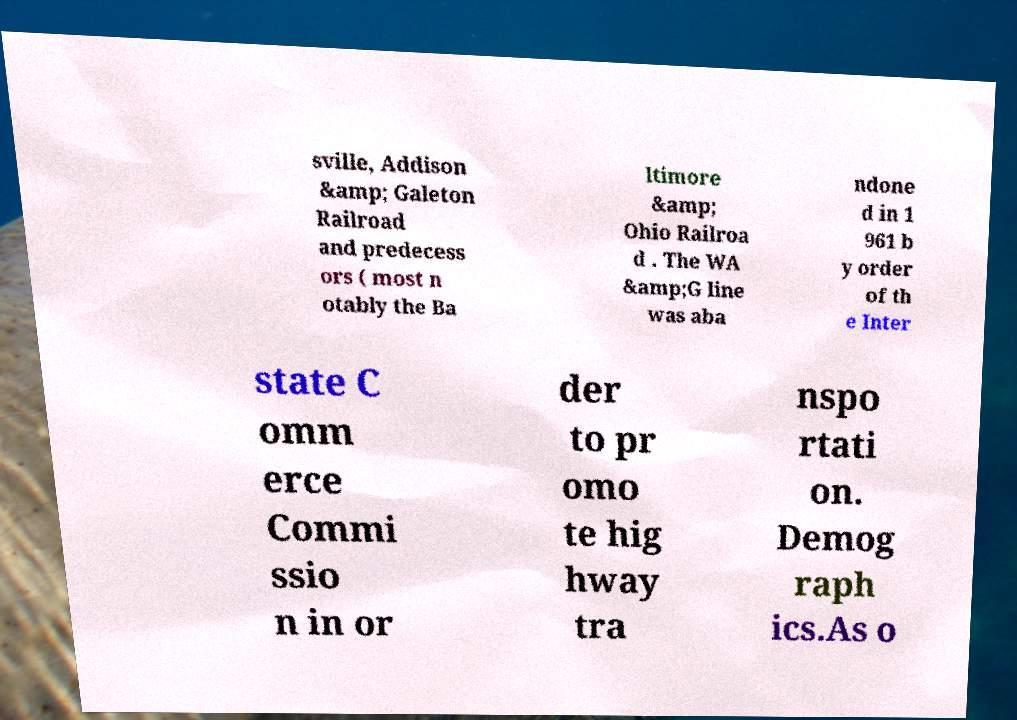Could you assist in decoding the text presented in this image and type it out clearly? sville, Addison &amp; Galeton Railroad and predecess ors ( most n otably the Ba ltimore &amp; Ohio Railroa d . The WA &amp;G line was aba ndone d in 1 961 b y order of th e Inter state C omm erce Commi ssio n in or der to pr omo te hig hway tra nspo rtati on. Demog raph ics.As o 